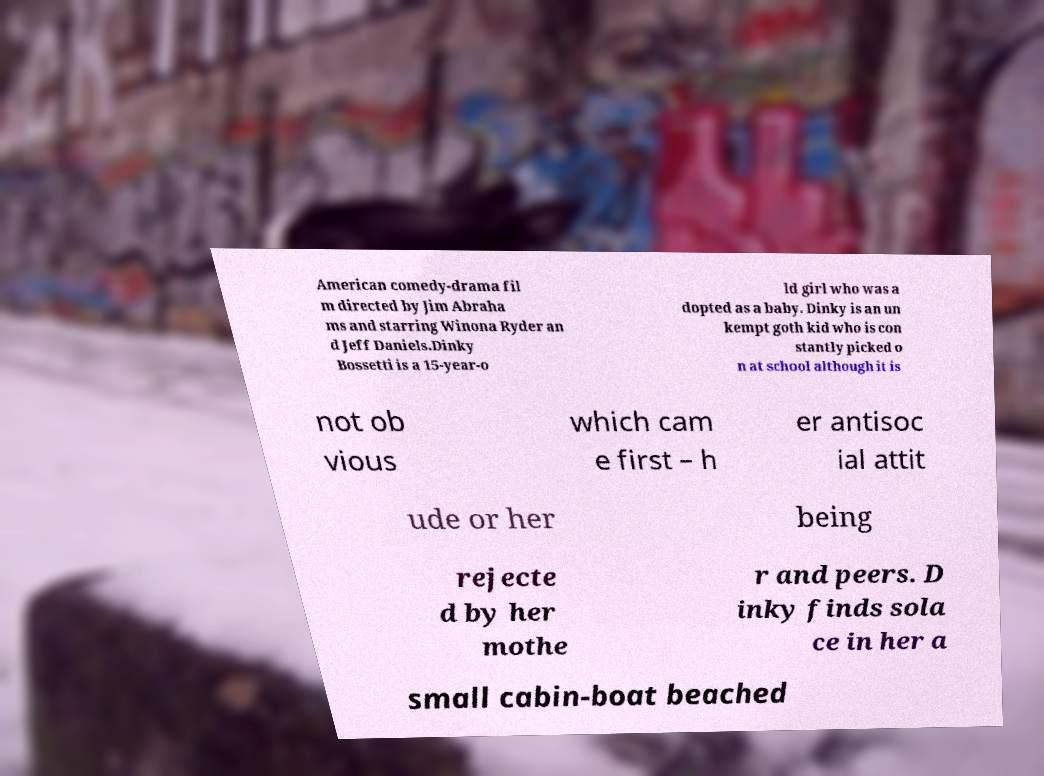What messages or text are displayed in this image? I need them in a readable, typed format. American comedy-drama fil m directed by Jim Abraha ms and starring Winona Ryder an d Jeff Daniels.Dinky Bossetti is a 15-year-o ld girl who was a dopted as a baby. Dinky is an un kempt goth kid who is con stantly picked o n at school although it is not ob vious which cam e first – h er antisoc ial attit ude or her being rejecte d by her mothe r and peers. D inky finds sola ce in her a small cabin-boat beached 